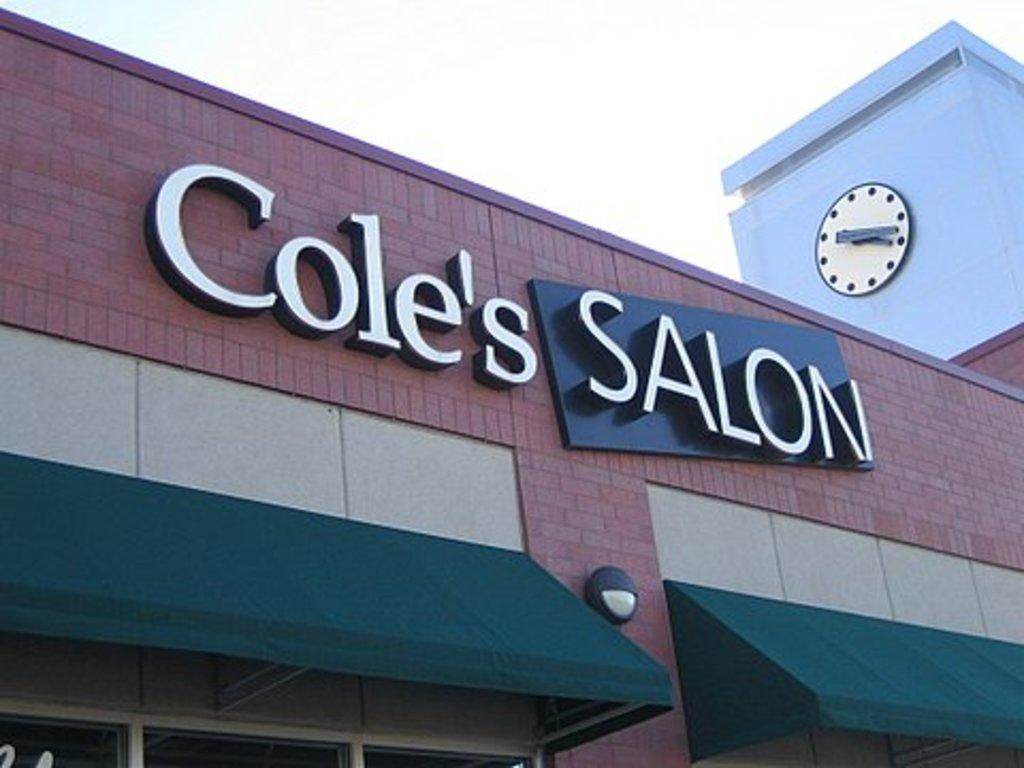<image>
Share a concise interpretation of the image provided. Cole's Salon building with a clock above it 